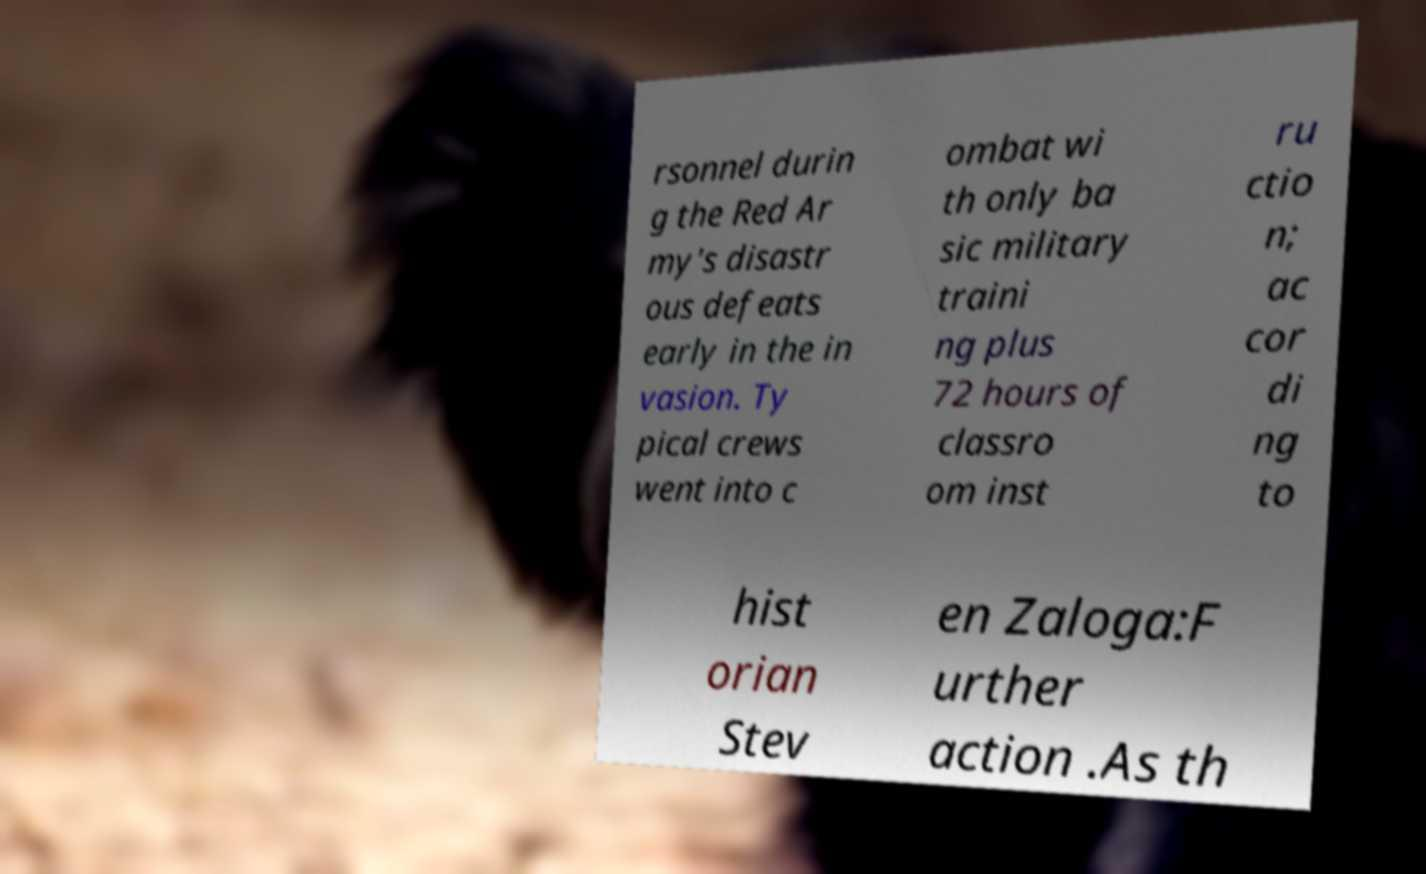Can you accurately transcribe the text from the provided image for me? rsonnel durin g the Red Ar my's disastr ous defeats early in the in vasion. Ty pical crews went into c ombat wi th only ba sic military traini ng plus 72 hours of classro om inst ru ctio n; ac cor di ng to hist orian Stev en Zaloga:F urther action .As th 